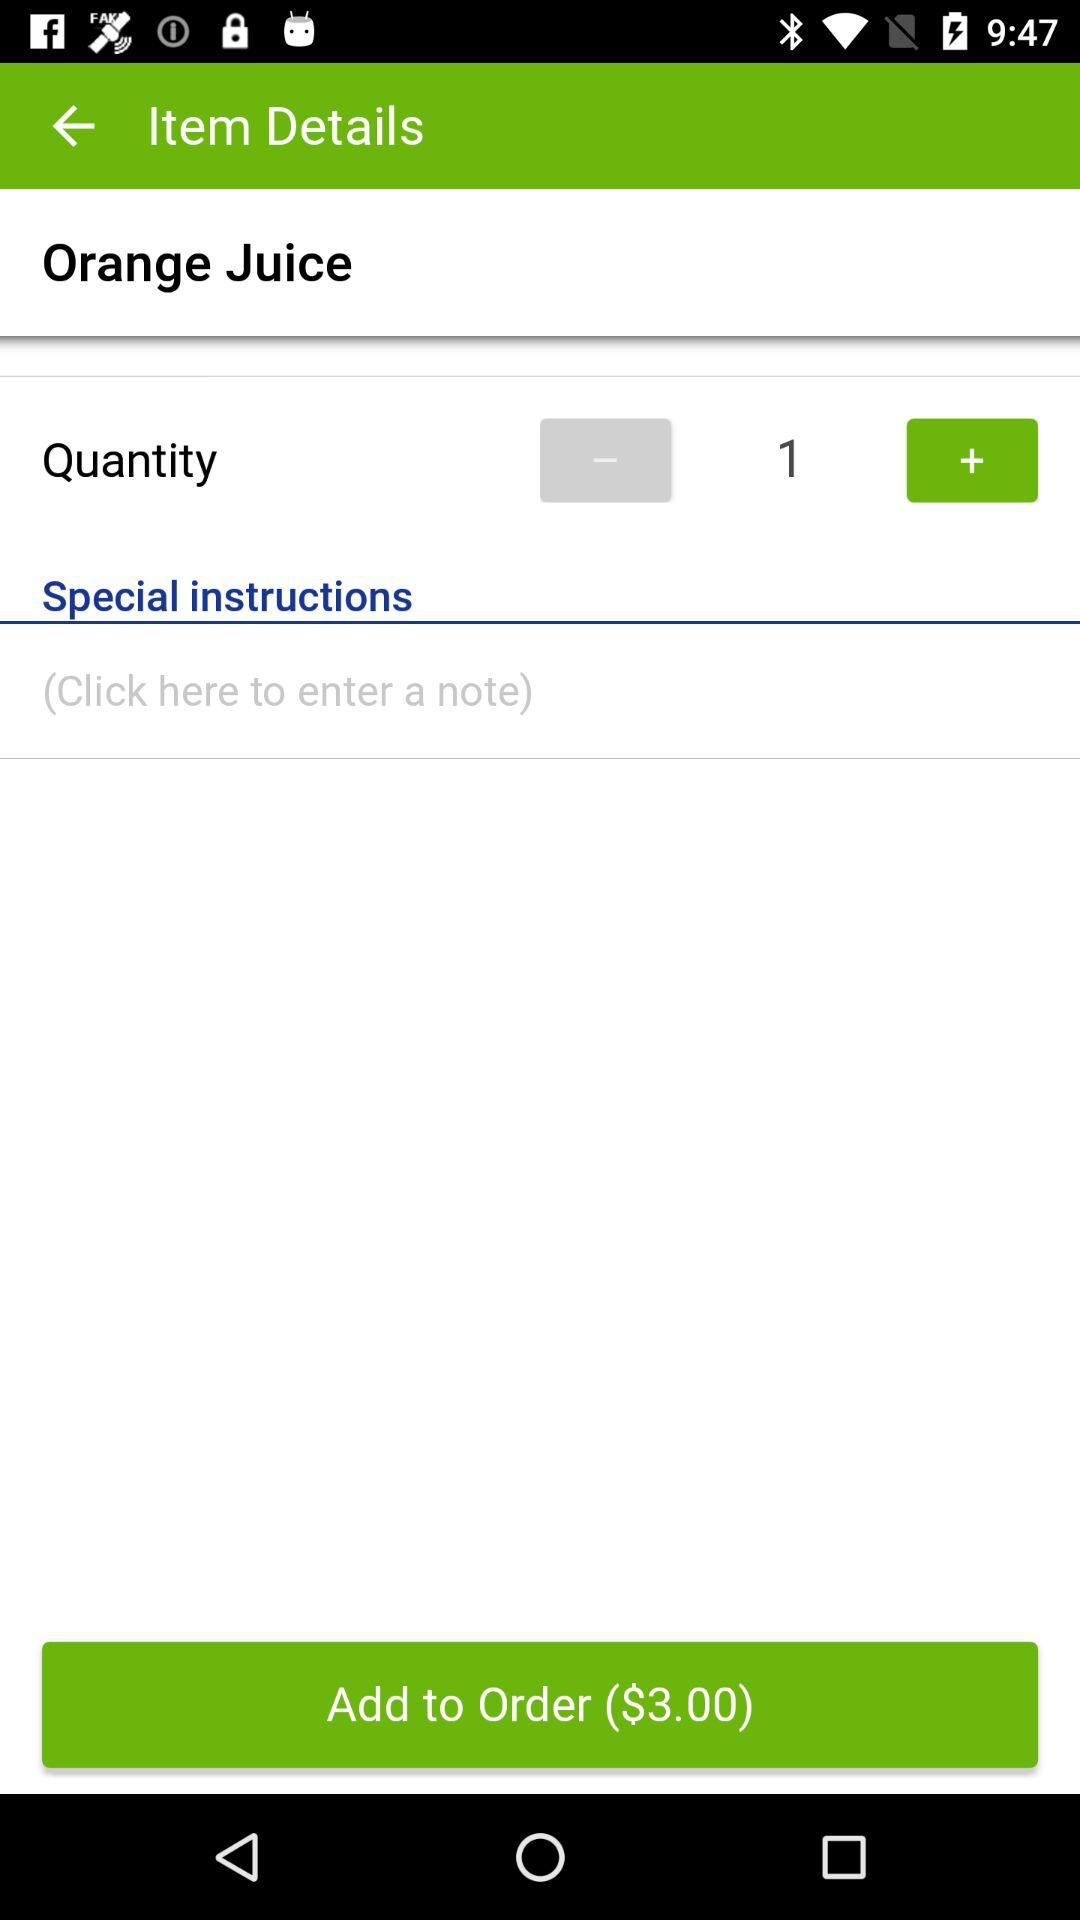What is the quantity of orange juice? The quantity of orange juice is 1. 